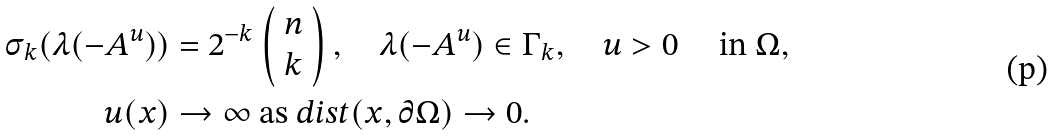<formula> <loc_0><loc_0><loc_500><loc_500>\sigma _ { k } ( \lambda ( - A ^ { u } ) ) & = 2 ^ { - k } \left ( \begin{array} { c } n \\ k \end{array} \right ) , \quad \lambda ( - A ^ { u } ) \in \Gamma _ { k } , \quad u > 0 \quad \text { in } \Omega , \\ u ( x ) & \rightarrow \infty \text { as } d i s t ( x , \partial \Omega ) \rightarrow 0 .</formula> 